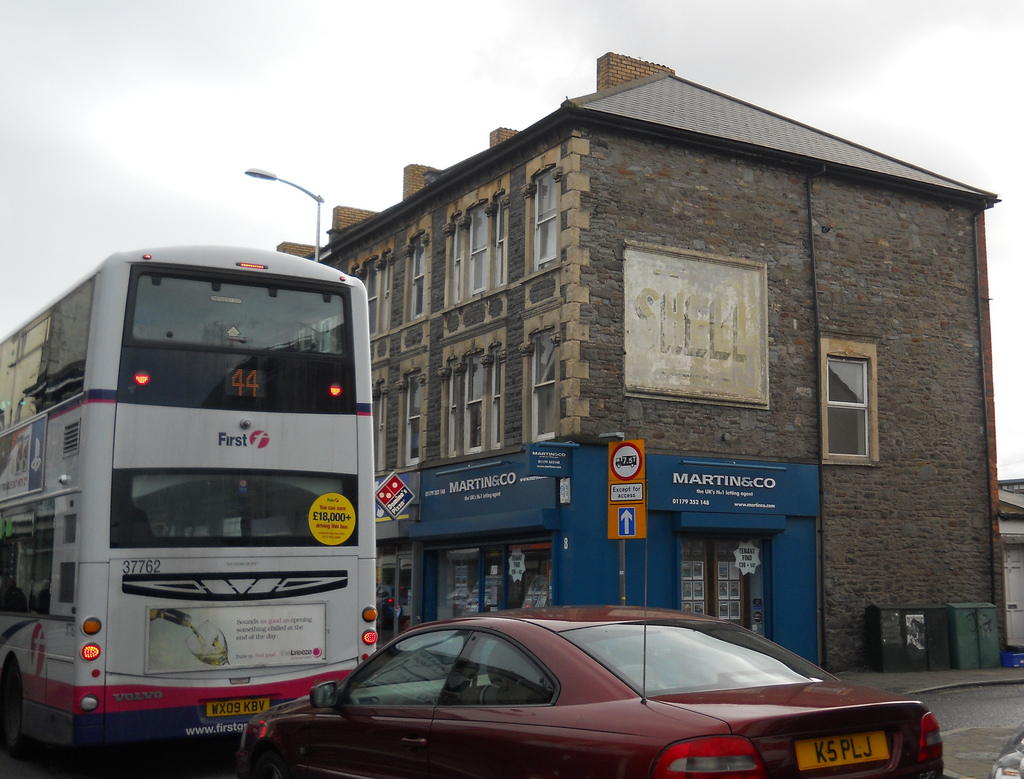Please provide the bounding box coordinate of the region this sentence describes: orange and black digital display. The bounding box coordinate for the orange and black digital display is approximately [0.2, 0.47, 0.27, 0.52]. This marks the precise area of the digital display, ensuring accurate referencing. 